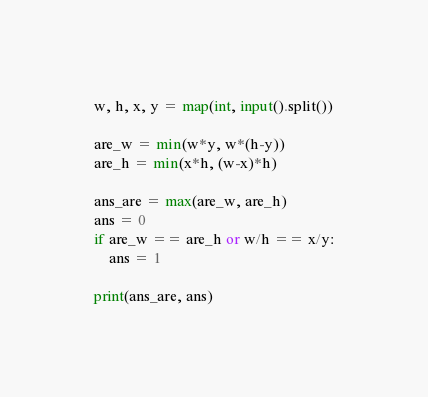Convert code to text. <code><loc_0><loc_0><loc_500><loc_500><_Python_>w, h, x, y = map(int, input().split())

are_w = min(w*y, w*(h-y))
are_h = min(x*h, (w-x)*h)

ans_are = max(are_w, are_h)
ans = 0
if are_w == are_h or w/h == x/y:
    ans = 1

print(ans_are, ans)

</code> 